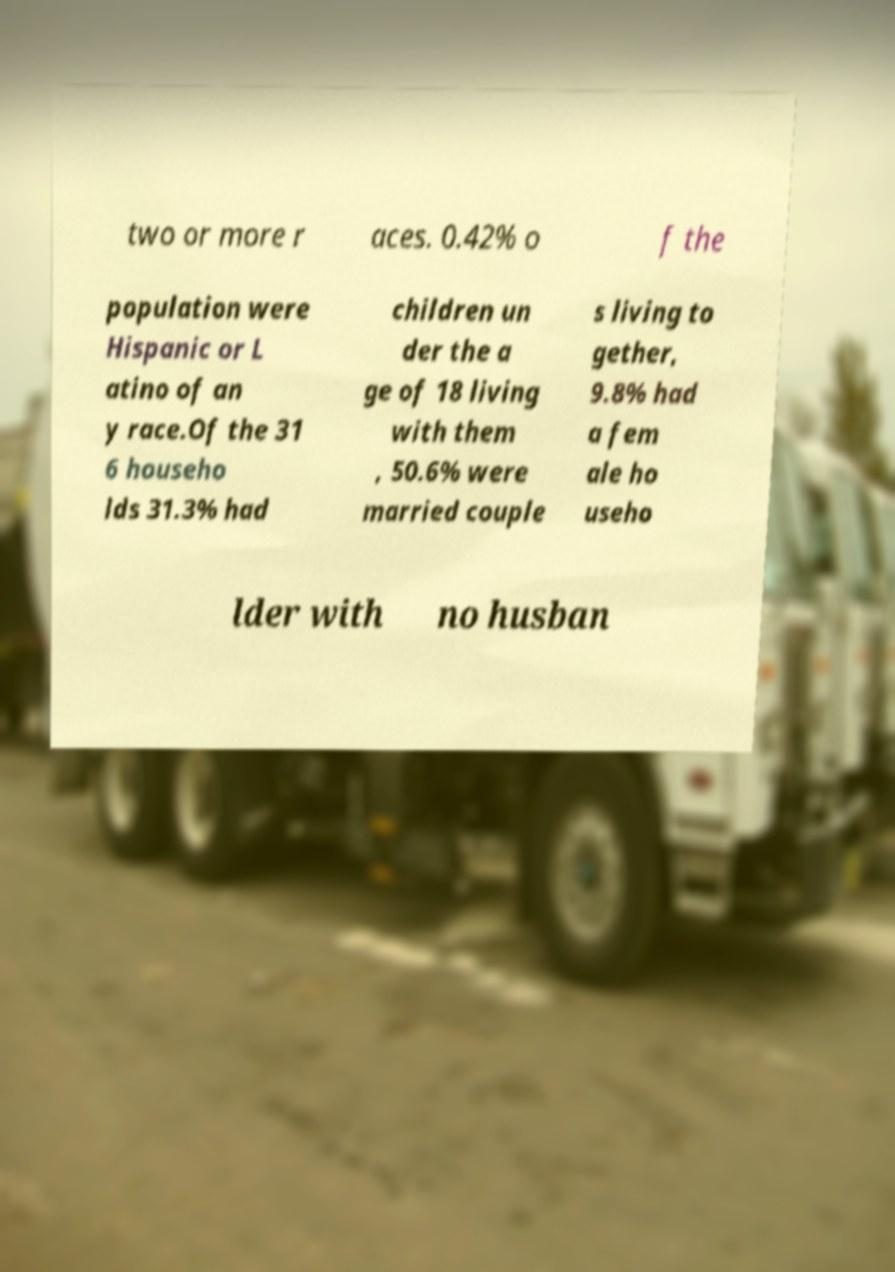Could you assist in decoding the text presented in this image and type it out clearly? two or more r aces. 0.42% o f the population were Hispanic or L atino of an y race.Of the 31 6 househo lds 31.3% had children un der the a ge of 18 living with them , 50.6% were married couple s living to gether, 9.8% had a fem ale ho useho lder with no husban 